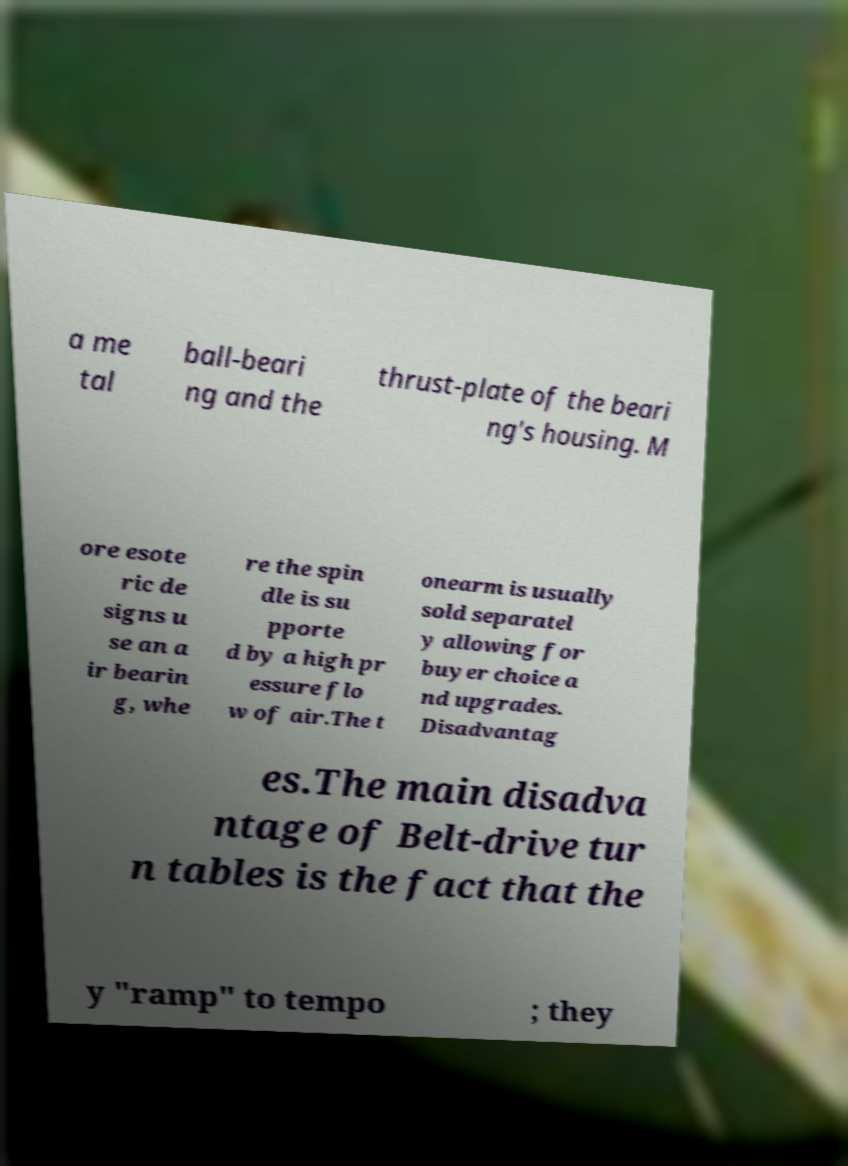Can you read and provide the text displayed in the image?This photo seems to have some interesting text. Can you extract and type it out for me? a me tal ball-beari ng and the thrust-plate of the beari ng's housing. M ore esote ric de signs u se an a ir bearin g, whe re the spin dle is su pporte d by a high pr essure flo w of air.The t onearm is usually sold separatel y allowing for buyer choice a nd upgrades. Disadvantag es.The main disadva ntage of Belt-drive tur n tables is the fact that the y "ramp" to tempo ; they 